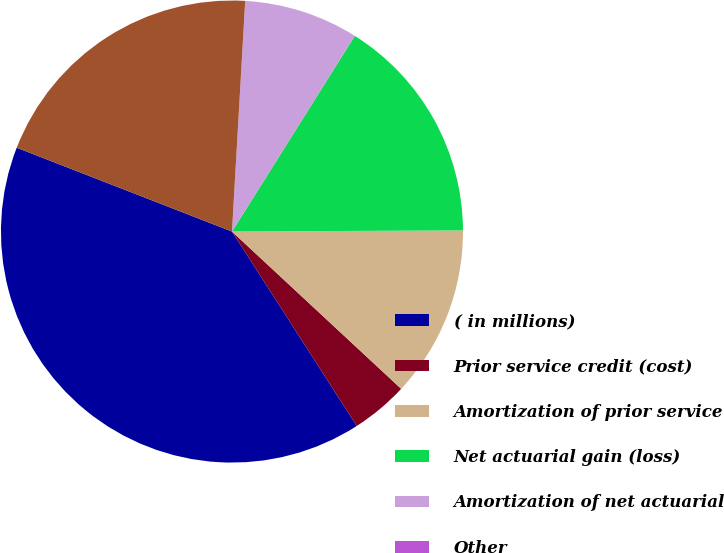<chart> <loc_0><loc_0><loc_500><loc_500><pie_chart><fcel>( in millions)<fcel>Prior service credit (cost)<fcel>Amortization of prior service<fcel>Net actuarial gain (loss)<fcel>Amortization of net actuarial<fcel>Other<fcel>Total changes in accumulated<nl><fcel>39.99%<fcel>4.0%<fcel>12.0%<fcel>16.0%<fcel>8.0%<fcel>0.01%<fcel>20.0%<nl></chart> 